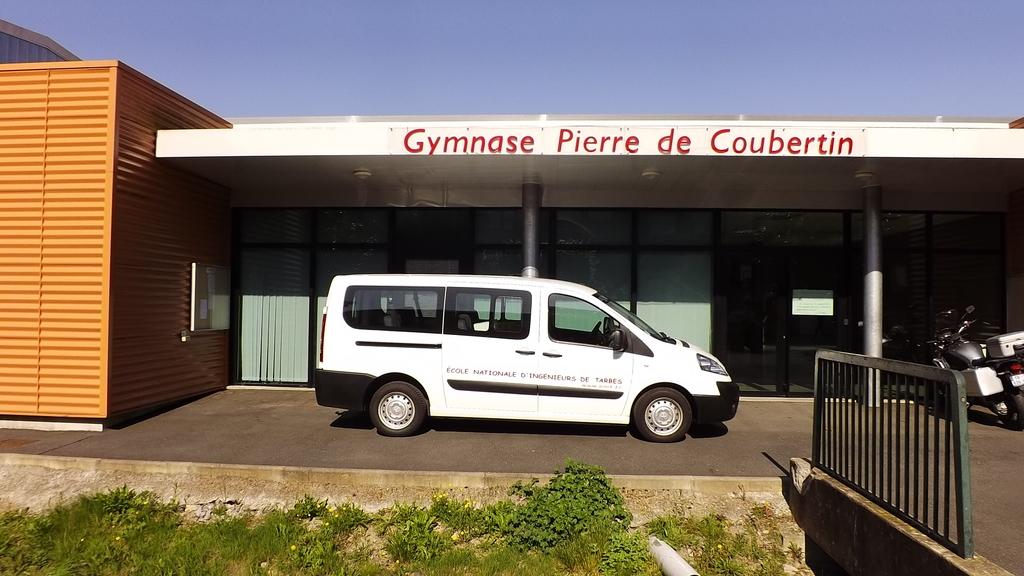What is the sign say?
Your answer should be compact. Gymnase pierre de coubertin. 